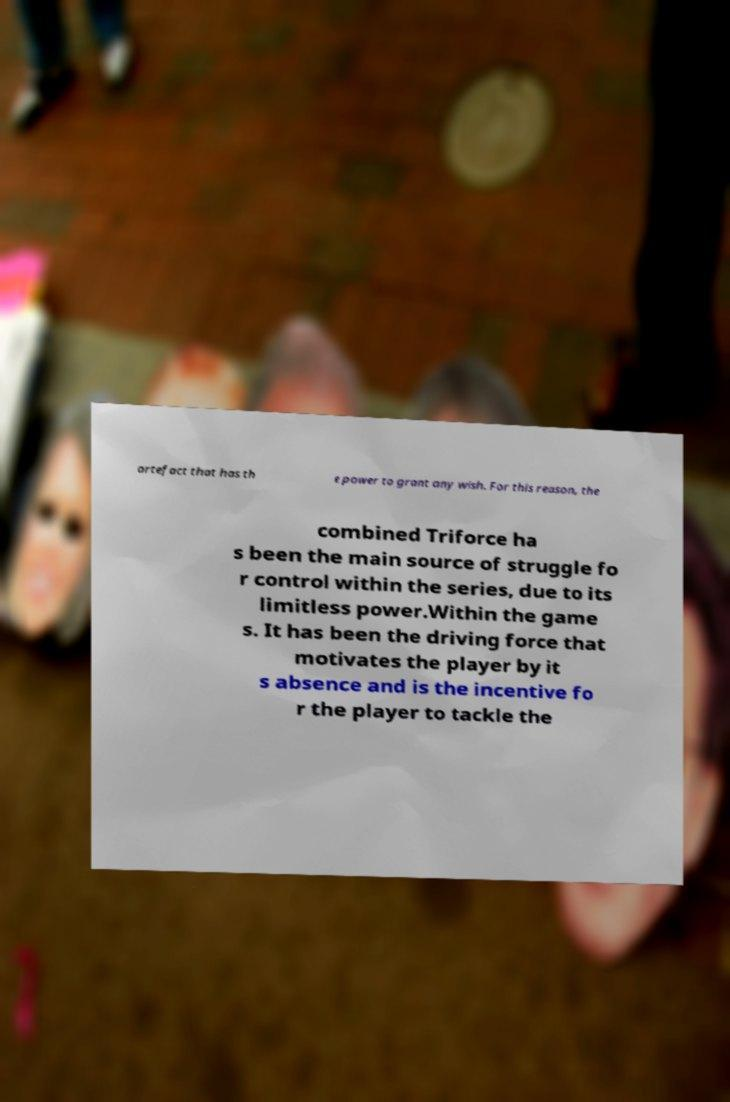There's text embedded in this image that I need extracted. Can you transcribe it verbatim? artefact that has th e power to grant any wish. For this reason, the combined Triforce ha s been the main source of struggle fo r control within the series, due to its limitless power.Within the game s. It has been the driving force that motivates the player by it s absence and is the incentive fo r the player to tackle the 